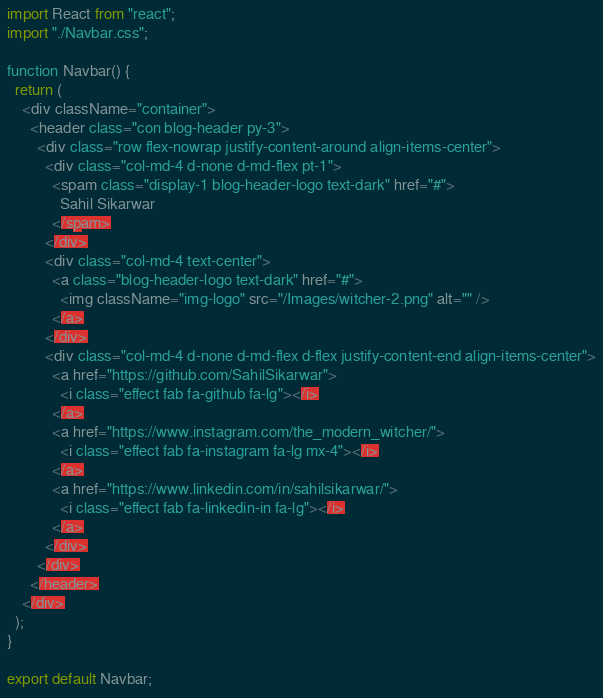Convert code to text. <code><loc_0><loc_0><loc_500><loc_500><_JavaScript_>import React from "react";
import "./Navbar.css";

function Navbar() {
  return (
    <div className="container">
      <header class="con blog-header py-3">
        <div class="row flex-nowrap justify-content-around align-items-center">
          <div class="col-md-4 d-none d-md-flex pt-1">
            <spam class="display-1 blog-header-logo text-dark" href="#">
              Sahil Sikarwar
            </spam>
          </div>
          <div class="col-md-4 text-center">
            <a class="blog-header-logo text-dark" href="#">
              <img className="img-logo" src="/Images/witcher-2.png" alt="" />
            </a>
          </div>
          <div class="col-md-4 d-none d-md-flex d-flex justify-content-end align-items-center">
            <a href="https://github.com/SahilSikarwar">
              <i class="effect fab fa-github fa-lg"></i>
            </a>
            <a href="https://www.instagram.com/the_modern_witcher/">
              <i class="effect fab fa-instagram fa-lg mx-4"></i>
            </a>
            <a href="https://www.linkedin.com/in/sahilsikarwar/">
              <i class="effect fab fa-linkedin-in fa-lg"></i>
            </a>
          </div>
        </div>
      </header>
    </div>
  );
}

export default Navbar;
</code> 